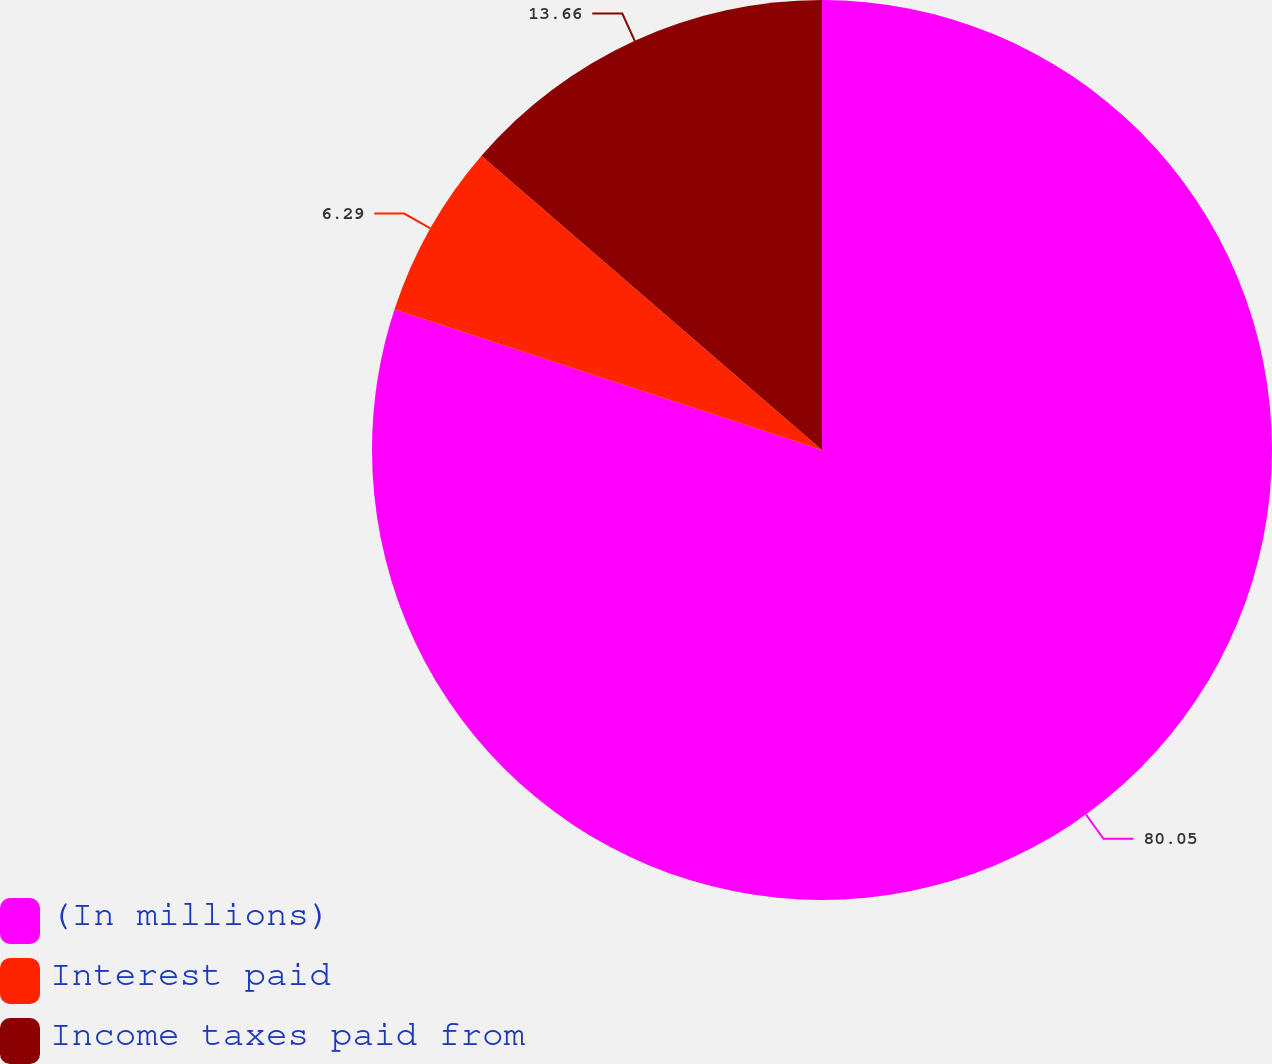Convert chart. <chart><loc_0><loc_0><loc_500><loc_500><pie_chart><fcel>(In millions)<fcel>Interest paid<fcel>Income taxes paid from<nl><fcel>80.05%<fcel>6.29%<fcel>13.66%<nl></chart> 